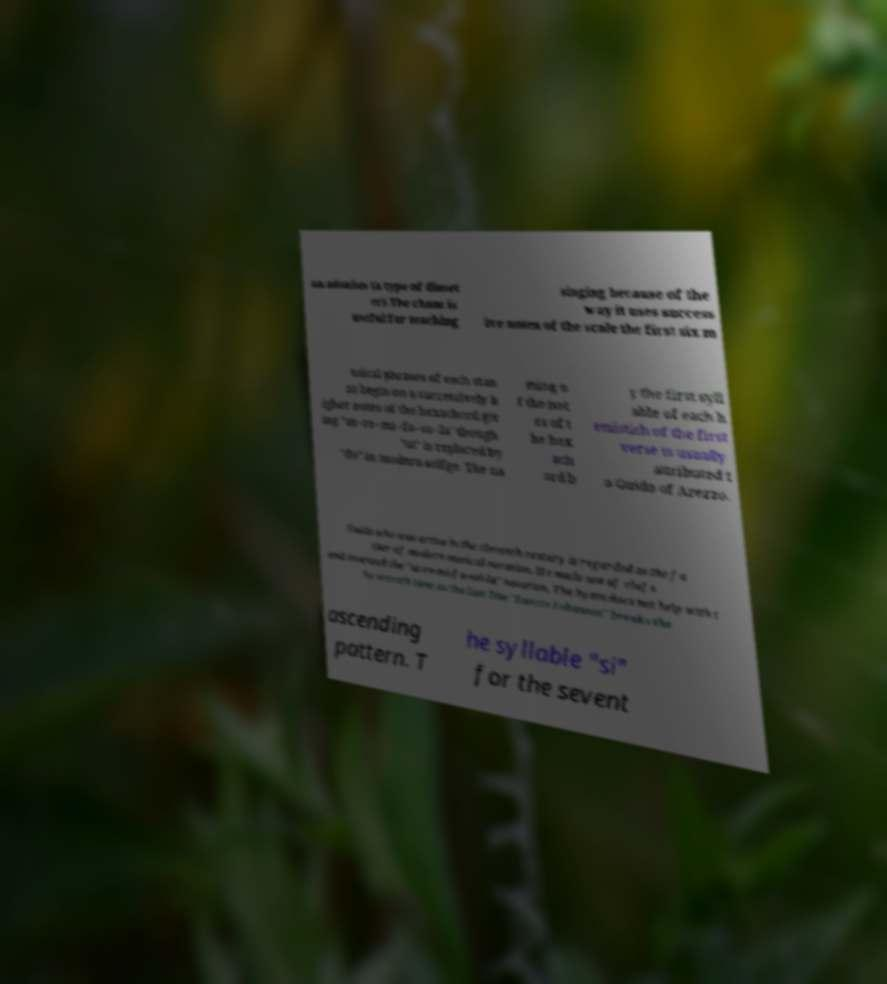What messages or text are displayed in this image? I need them in a readable, typed format. an adonius (a type of dimet er).The chant is useful for teaching singing because of the way it uses success ive notes of the scale the first six m usical phrases of each stan za begin on a successively h igher notes of the hexachord giv ing "ut–re–mi–fa–so–la" though "ut" is replaced by "do" in modern solfge. The na ming o f the not es of t he hex ach ord b y the first syll able of each h emistich of the first verse is usually attributed t o Guido of Arezzo. Guido who was active in the eleventh century is regarded as the fa ther of modern musical notation. He made use of clefs and invented the "ut-re-mi-fa-sol-la" notation. The hymn does not help with t he seventh tone as the last line "Sancte Iohannes" breaks the ascending pattern. T he syllable "si" for the sevent 